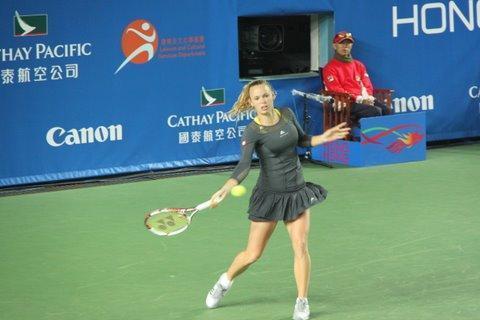How many people are visible?
Give a very brief answer. 2. 